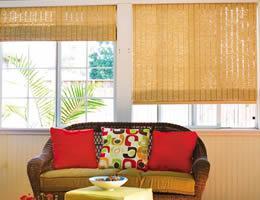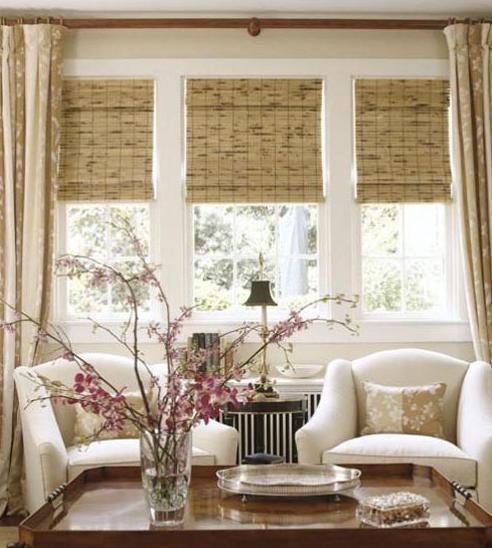The first image is the image on the left, the second image is the image on the right. Analyze the images presented: Is the assertion "A couch is backed up against a row of windows in one of the images." valid? Answer yes or no. Yes. The first image is the image on the left, the second image is the image on the right. Analyze the images presented: Is the assertion "There are five shades." valid? Answer yes or no. Yes. 